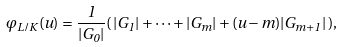Convert formula to latex. <formula><loc_0><loc_0><loc_500><loc_500>\varphi _ { L / K } ( u ) = \frac { 1 } { | G _ { 0 } | } ( \, | G _ { 1 } | + \dots + | G _ { m } | + ( u - m ) | G _ { m + 1 } | \, ) ,</formula> 